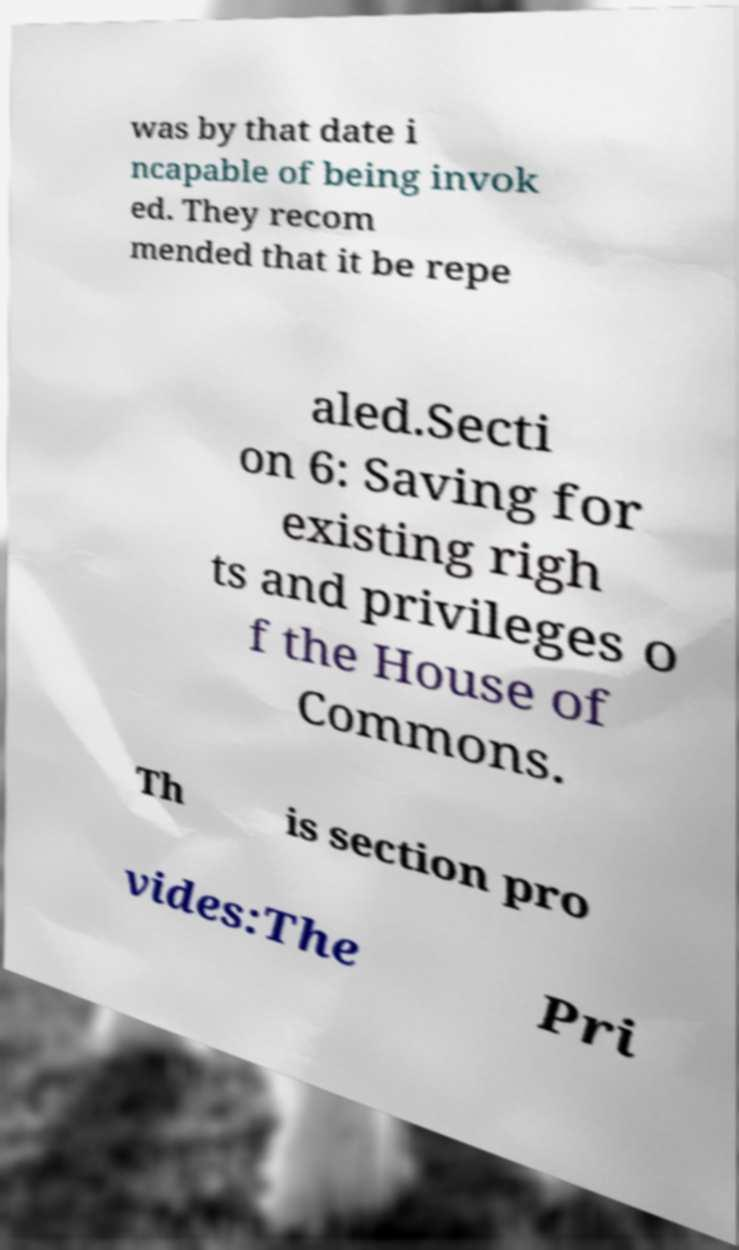Please read and relay the text visible in this image. What does it say? was by that date i ncapable of being invok ed. They recom mended that it be repe aled.Secti on 6: Saving for existing righ ts and privileges o f the House of Commons. Th is section pro vides:The Pri 